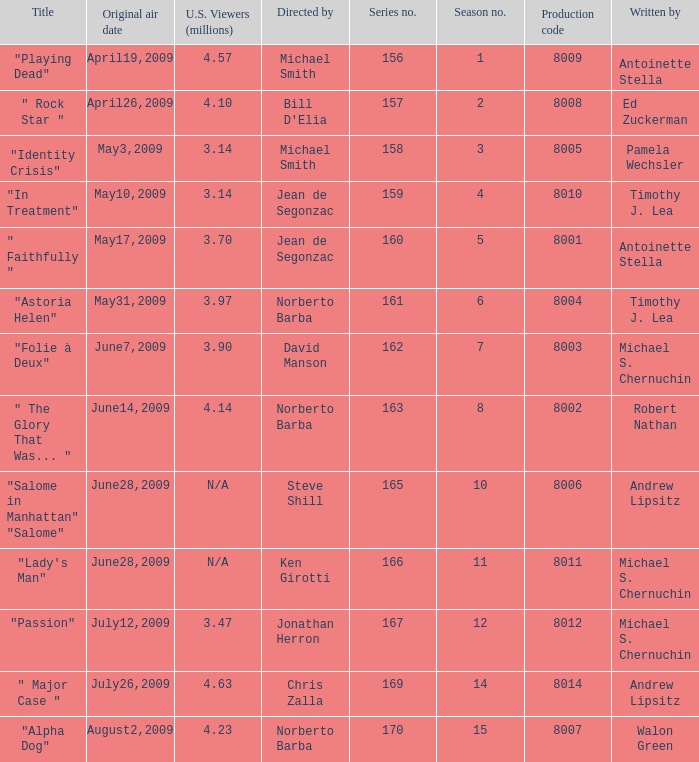Which is the  maximun serie episode number when the millions of north american spectators is 3.14? 159.0. 